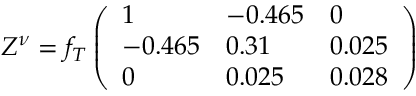Convert formula to latex. <formula><loc_0><loc_0><loc_500><loc_500>Z ^ { \nu } = f _ { T } \left ( \begin{array} { l l l } { 1 } & { - 0 . 4 6 5 } & { 0 } \\ { - 0 . 4 6 5 } & { 0 . 3 1 } & { 0 . 0 2 5 } \\ { 0 } & { 0 . 0 2 5 } & { 0 . 0 2 8 } \end{array} \right )</formula> 